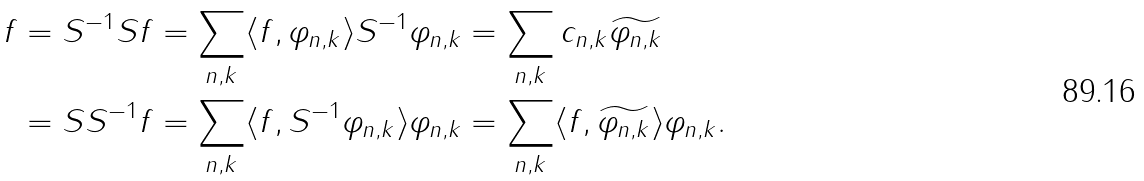Convert formula to latex. <formula><loc_0><loc_0><loc_500><loc_500>f & = S ^ { - 1 } S f = \sum _ { n , k } \langle f , \varphi _ { n , k } \rangle S ^ { - 1 } \varphi _ { n , k } = \sum _ { n , k } c _ { n , k } \widetilde { \varphi _ { n , k } } \\ & = S S ^ { - 1 } f = \sum _ { n , k } \langle f , S ^ { - 1 } \varphi _ { n , k } \rangle \varphi _ { n , k } = \sum _ { n , k } \langle f , \widetilde { \varphi _ { n , k } } \rangle \varphi _ { n , k } .</formula> 